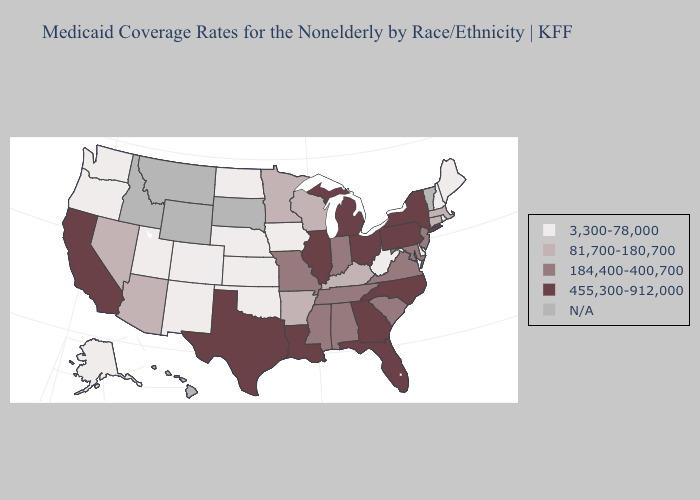What is the value of Virginia?
Keep it brief. 184,400-400,700. Does Maine have the highest value in the Northeast?
Keep it brief. No. What is the highest value in the MidWest ?
Short answer required. 455,300-912,000. Name the states that have a value in the range 3,300-78,000?
Quick response, please. Alaska, Colorado, Delaware, Iowa, Kansas, Maine, Nebraska, New Hampshire, New Mexico, North Dakota, Oklahoma, Oregon, Rhode Island, Utah, Washington, West Virginia. What is the value of North Carolina?
Concise answer only. 455,300-912,000. What is the value of Louisiana?
Keep it brief. 455,300-912,000. What is the value of Vermont?
Give a very brief answer. N/A. What is the highest value in the South ?
Quick response, please. 455,300-912,000. Does New York have the highest value in the Northeast?
Keep it brief. Yes. Does the first symbol in the legend represent the smallest category?
Write a very short answer. Yes. Name the states that have a value in the range 184,400-400,700?
Write a very short answer. Alabama, Indiana, Maryland, Mississippi, Missouri, New Jersey, South Carolina, Tennessee, Virginia. What is the value of South Carolina?
Keep it brief. 184,400-400,700. What is the lowest value in the South?
Write a very short answer. 3,300-78,000. 